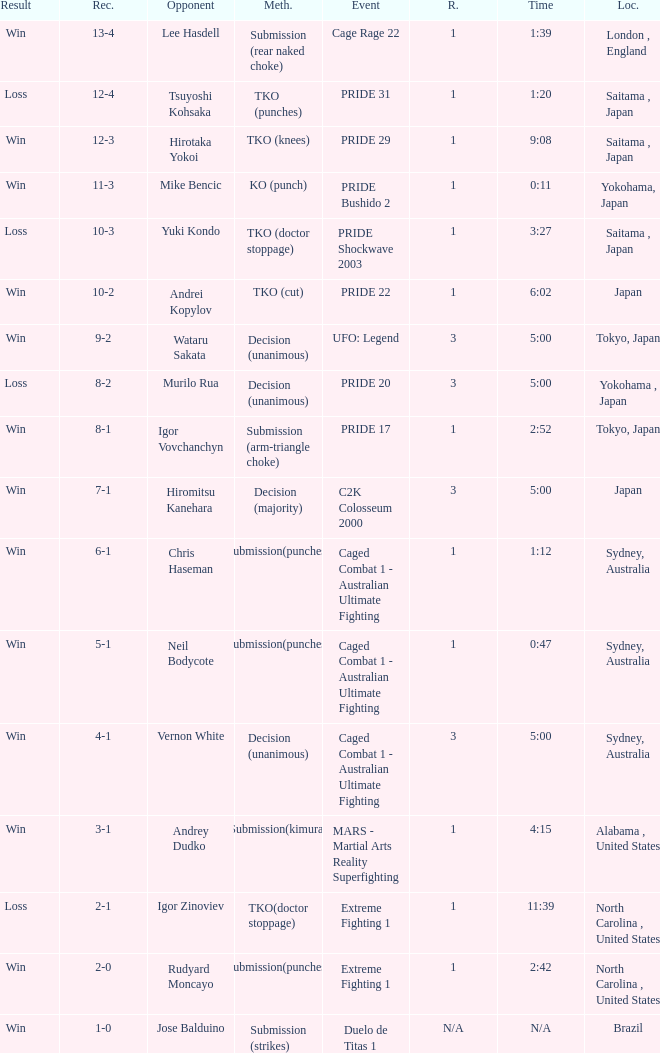Which Res has a Method of decision (unanimous) and an Opponent of Wataru Sakata? Win. 